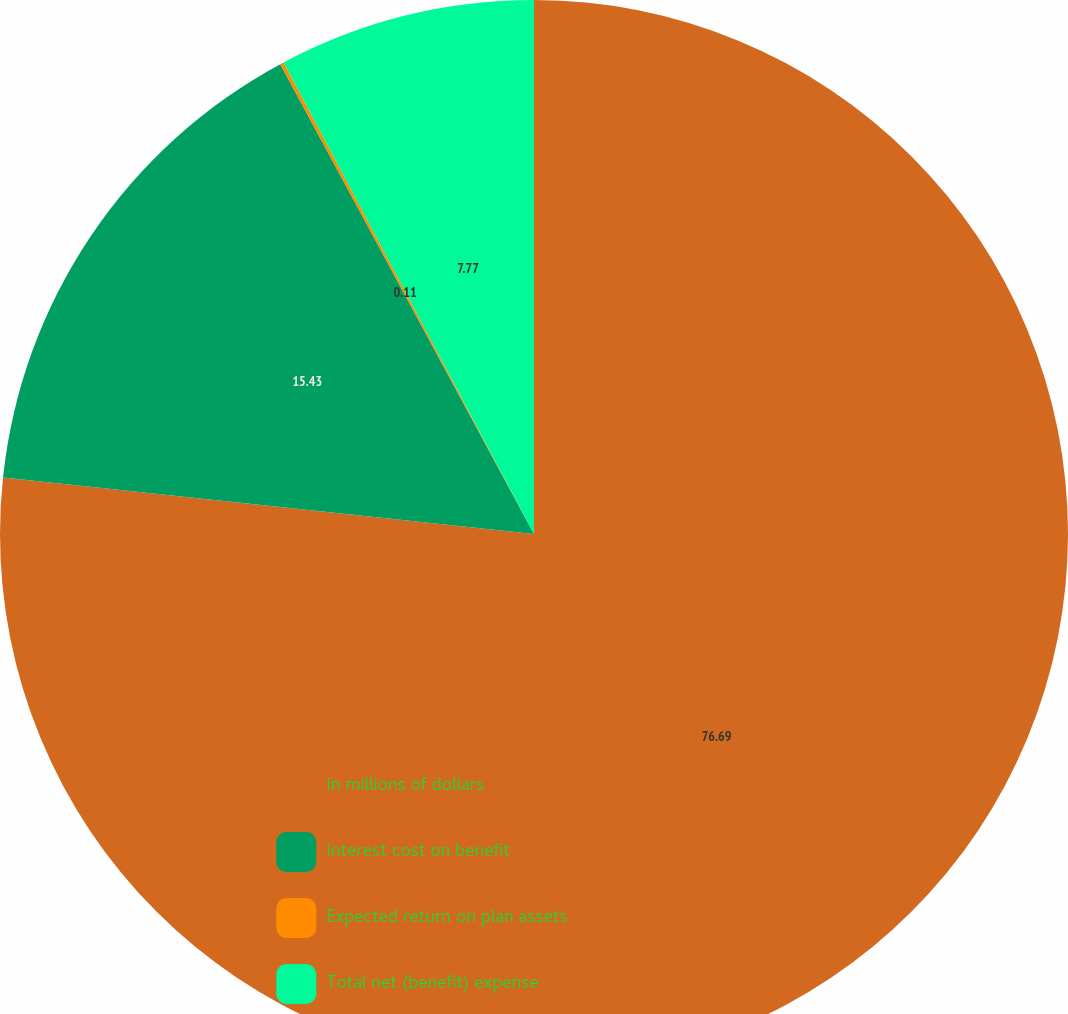<chart> <loc_0><loc_0><loc_500><loc_500><pie_chart><fcel>In millions of dollars<fcel>Interest cost on benefit<fcel>Expected return on plan assets<fcel>Total net (benefit) expense<nl><fcel>76.69%<fcel>15.43%<fcel>0.11%<fcel>7.77%<nl></chart> 